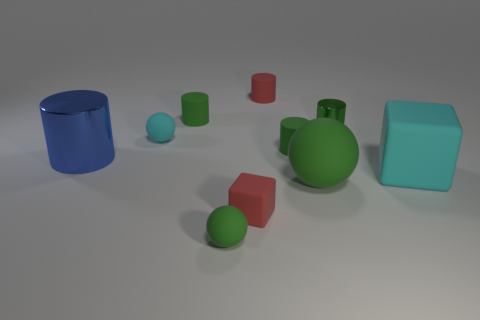Subtract all tiny spheres. How many spheres are left? 1 Subtract all cyan balls. How many balls are left? 2 Subtract all gray cylinders. How many red blocks are left? 1 Subtract 2 cylinders. How many cylinders are left? 3 Subtract all green blocks. Subtract all gray balls. How many blocks are left? 2 Subtract all cyan metal cylinders. Subtract all big blue shiny cylinders. How many objects are left? 9 Add 6 big green rubber things. How many big green rubber things are left? 7 Add 8 large cyan metallic spheres. How many large cyan metallic spheres exist? 8 Subtract 0 gray balls. How many objects are left? 10 Subtract all blocks. How many objects are left? 8 